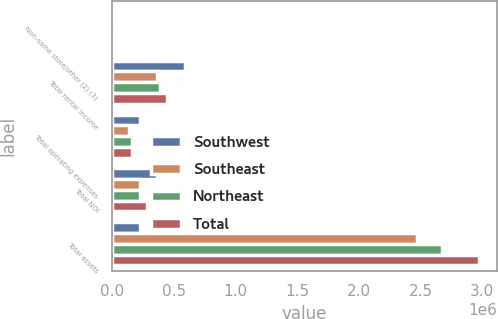Convert chart. <chart><loc_0><loc_0><loc_500><loc_500><stacked_bar_chart><ecel><fcel>Non-same store/other (2) (3)<fcel>Total rental income<fcel>Total operating expenses<fcel>Total NOI<fcel>Total assets<nl><fcel>Southwest<fcel>23195<fcel>589713<fcel>224150<fcel>365563<fcel>227965<nl><fcel>Southeast<fcel>2010<fcel>359512<fcel>131547<fcel>227965<fcel>2.47478e+06<nl><fcel>Northeast<fcel>4268<fcel>387507<fcel>160704<fcel>226803<fcel>2.6745e+06<nl><fcel>Total<fcel>16985<fcel>440061<fcel>157901<fcel>282160<fcel>2.9714e+06<nl></chart> 